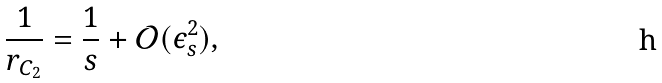Convert formula to latex. <formula><loc_0><loc_0><loc_500><loc_500>\frac { 1 } { r _ { { C } _ { 2 } } } = \frac { 1 } { s } + { \mathcal { O } } ( \epsilon _ { s } ^ { 2 } ) ,</formula> 